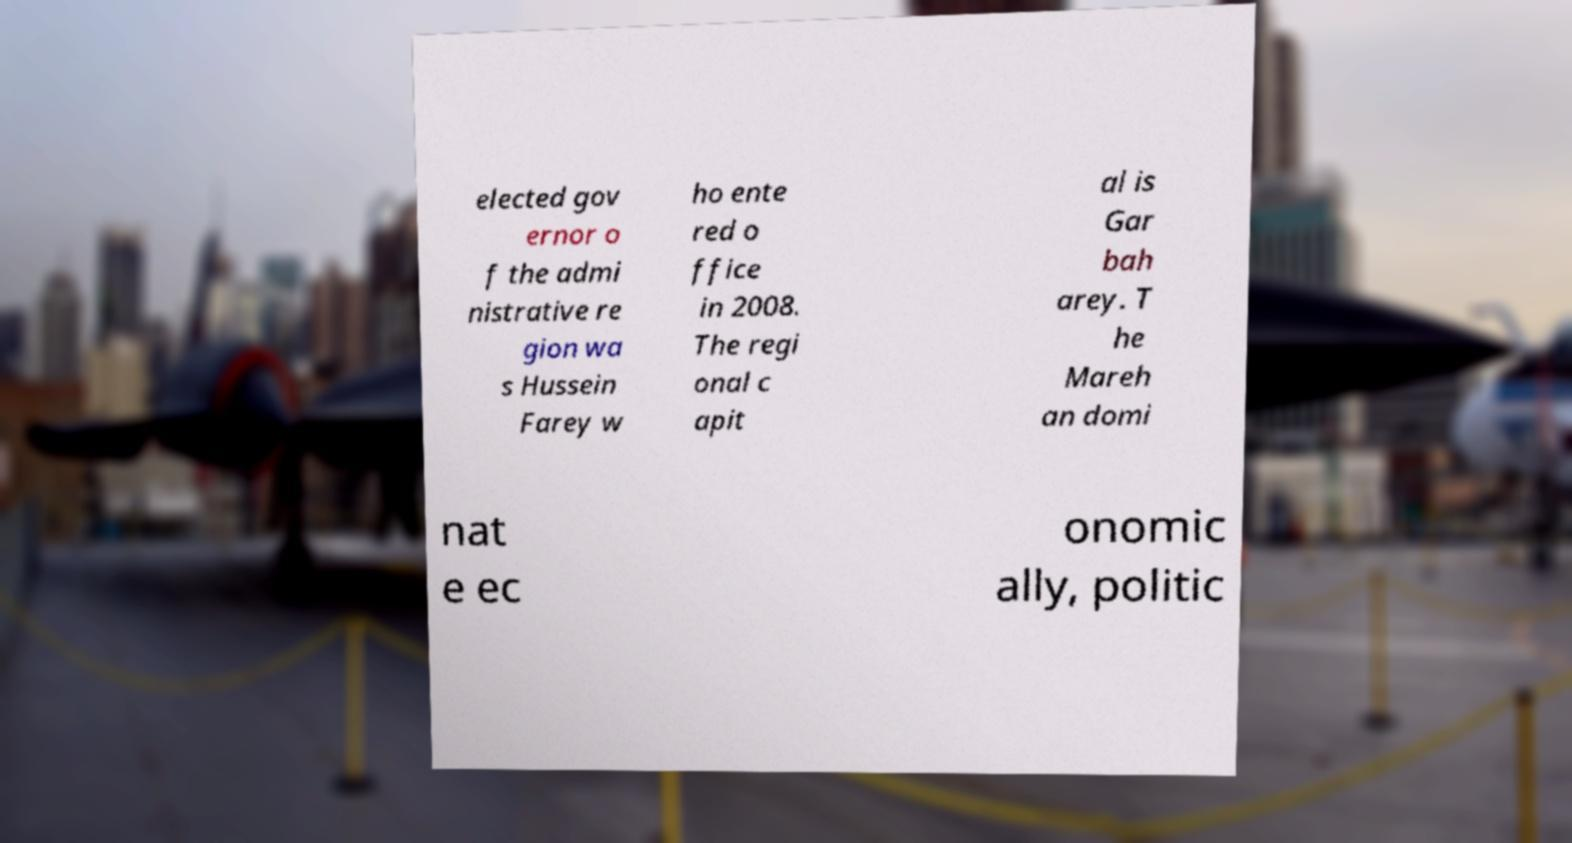Could you extract and type out the text from this image? elected gov ernor o f the admi nistrative re gion wa s Hussein Farey w ho ente red o ffice in 2008. The regi onal c apit al is Gar bah arey. T he Mareh an domi nat e ec onomic ally, politic 